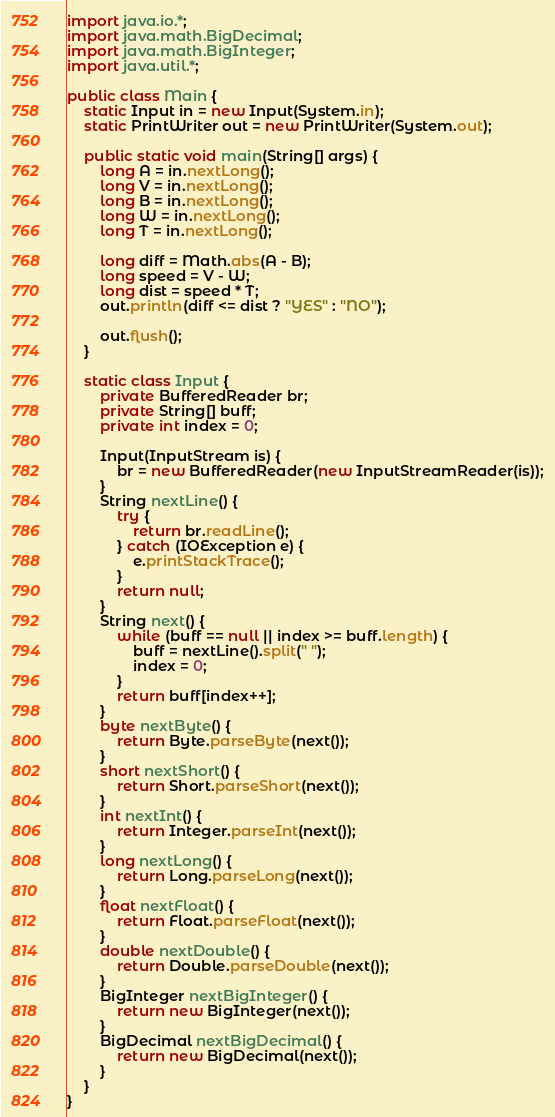<code> <loc_0><loc_0><loc_500><loc_500><_Java_>import java.io.*;
import java.math.BigDecimal;
import java.math.BigInteger;
import java.util.*;

public class Main {
    static Input in = new Input(System.in);
    static PrintWriter out = new PrintWriter(System.out);

    public static void main(String[] args) {
        long A = in.nextLong();
        long V = in.nextLong();
        long B = in.nextLong();
        long W = in.nextLong();
        long T = in.nextLong();

        long diff = Math.abs(A - B);
        long speed = V - W;
        long dist = speed * T;
        out.println(diff <= dist ? "YES" : "NO");

        out.flush();
    }

    static class Input {
        private BufferedReader br;
        private String[] buff;
        private int index = 0;

        Input(InputStream is) {
            br = new BufferedReader(new InputStreamReader(is));
        }
        String nextLine() {
            try {
                return br.readLine();
            } catch (IOException e) {
                e.printStackTrace();
            }
            return null;
        }
        String next() {
            while (buff == null || index >= buff.length) {
                buff = nextLine().split(" ");
                index = 0;
            }
            return buff[index++];
        }
        byte nextByte() {
            return Byte.parseByte(next());
        }
        short nextShort() {
            return Short.parseShort(next());
        }
        int nextInt() {
            return Integer.parseInt(next());
        }
        long nextLong() {
            return Long.parseLong(next());
        }
        float nextFloat() {
            return Float.parseFloat(next());
        }
        double nextDouble() {
            return Double.parseDouble(next());
        }
        BigInteger nextBigInteger() {
            return new BigInteger(next());
        }
        BigDecimal nextBigDecimal() {
            return new BigDecimal(next());
        }
    }
}

</code> 